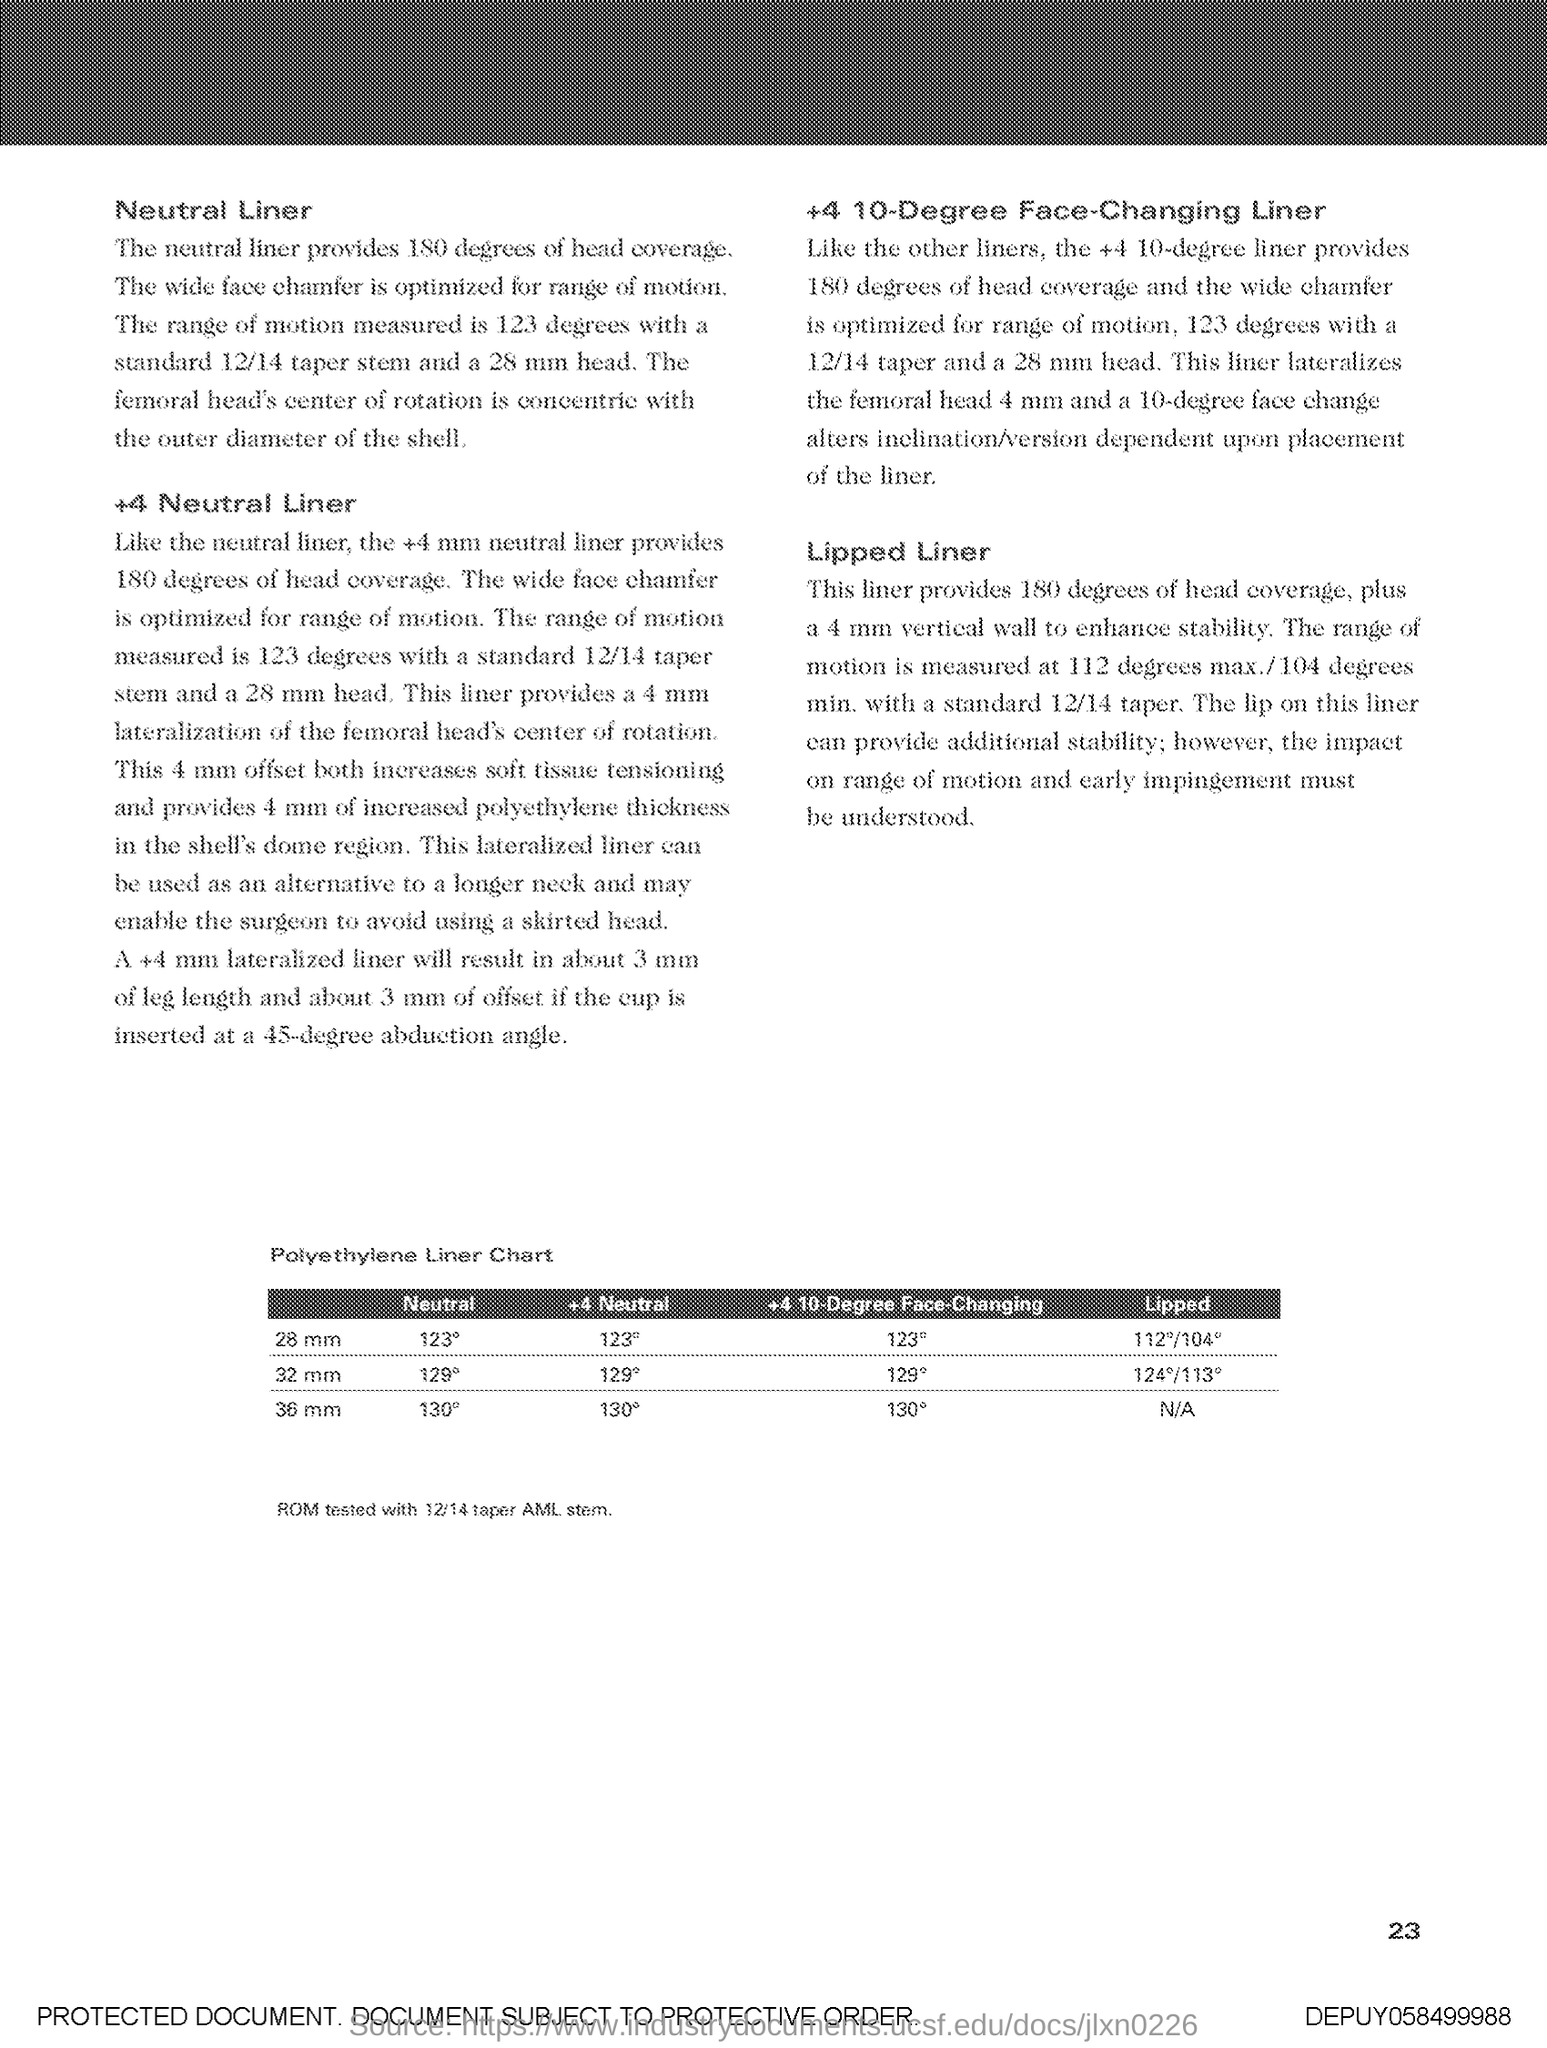Specify some key components in this picture. The table is named "Polyethylene Liner Chart. 